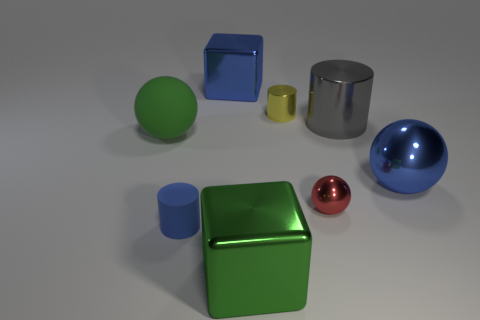How many objects are there in total? In total, there are seven objects: a large green cube, two cylinders, a large blue sphere, a small red sphere, and two cubes of different sizes and colors. 